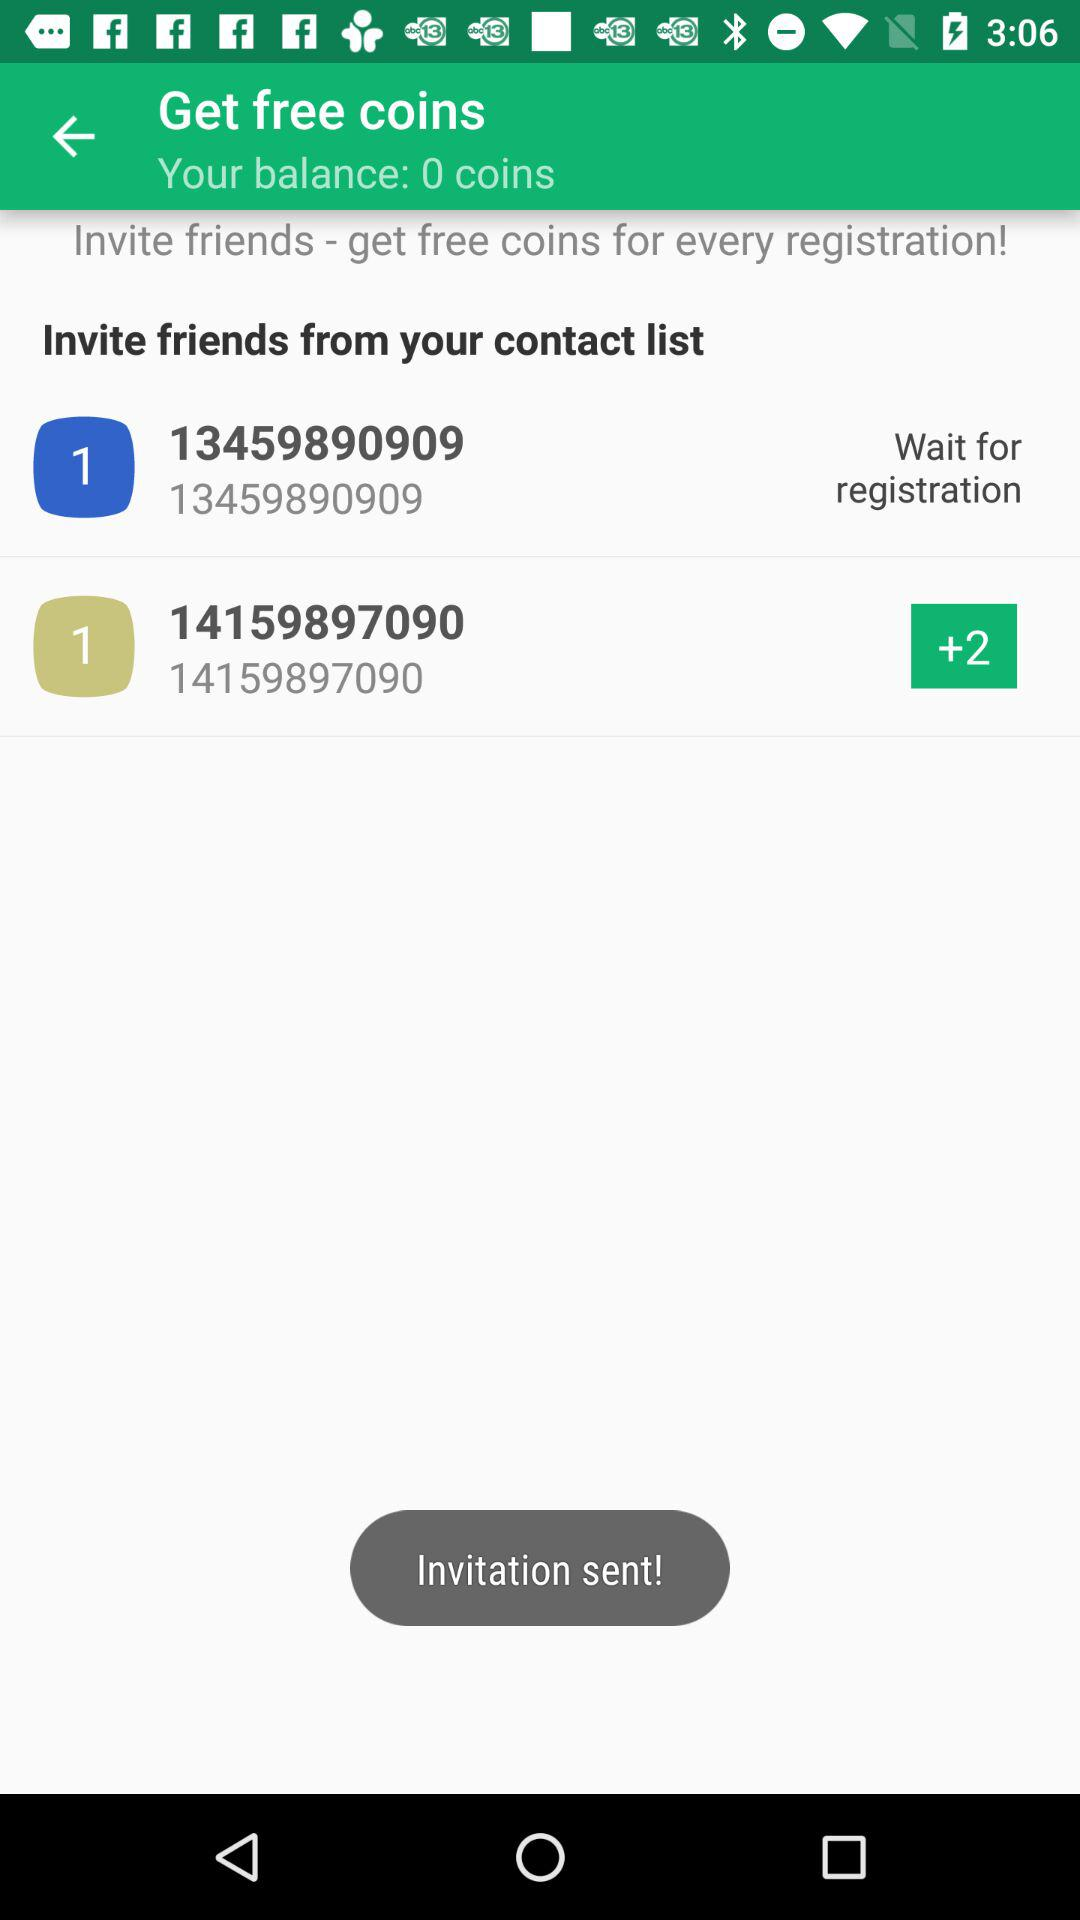What is the contact number? The contact numbers are 13459890909 and 14159897090. 